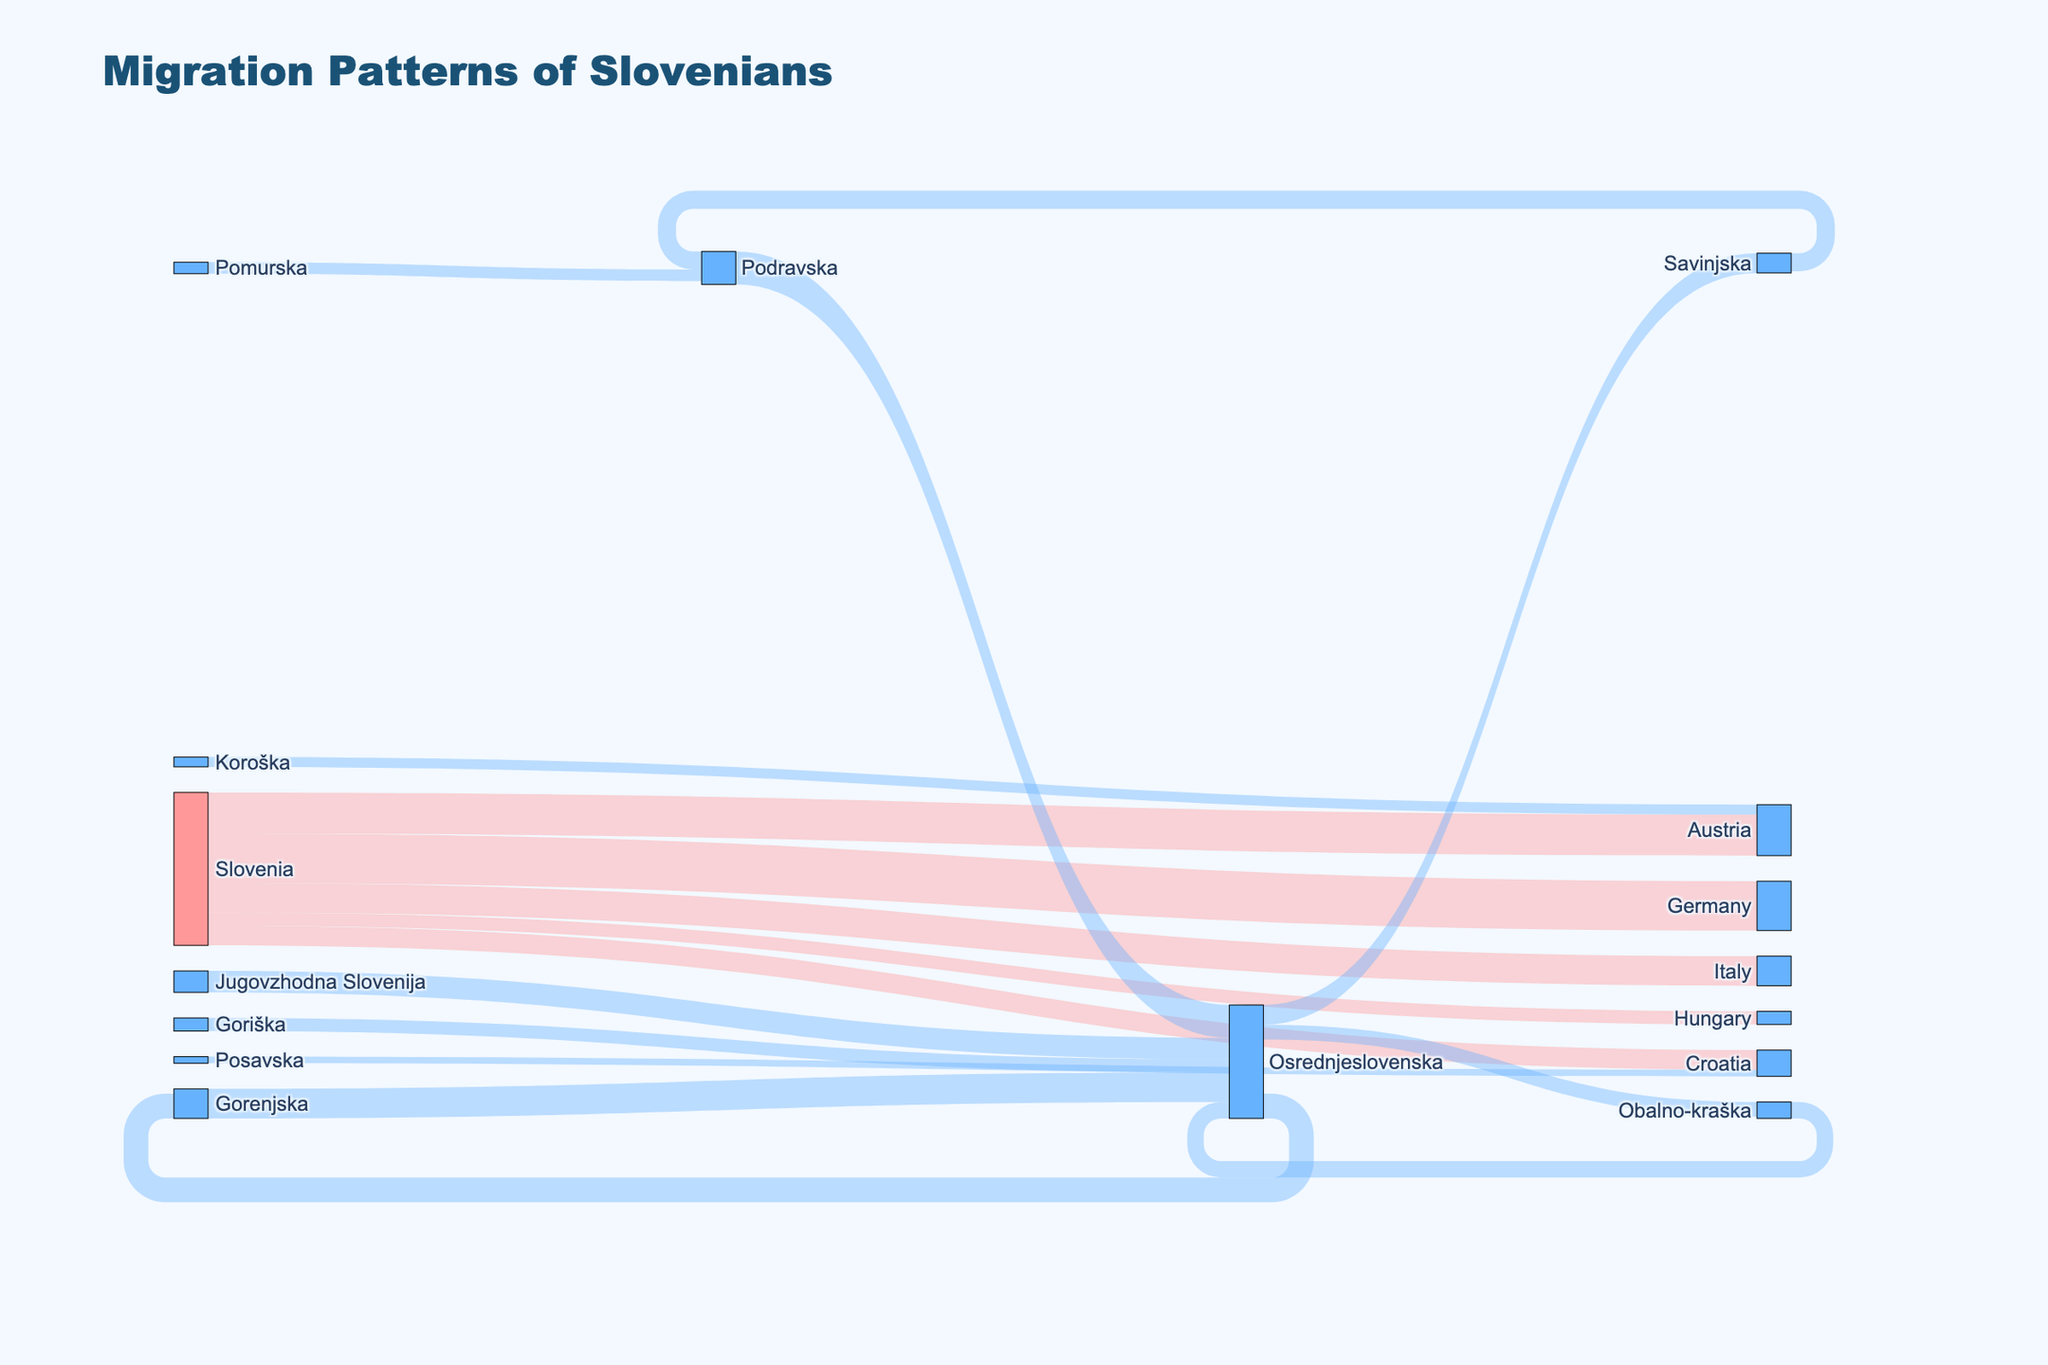What's the title of the figure? The title of the figure is displayed prominently at the top and reads "Migration Patterns of Slovenians".
Answer: Migration Patterns of Slovenians How many regions are listed as sources of migration within Slovenia? The figure shows the regions within Slovenia that are sources of migration, which are Osrednjeslovenska, Podravska, Gorenjska, Savinjska, Goriška, Jugovzhodna Slovenija, Pomurska, Obalno-kraška, Koroška, and Posavska.
Answer: 10 What is the total number of Slovenians migrating to Germany? The figure shows a flow from Slovenia to Germany with a value indicating the number of migrants. Based on the data provided, 3000 people migrate from Slovenia to Germany.
Answer: 3000 Compare the number of people migrating from Slovenia to Austria with those migrating from Slovenia to Italy. Which is higher and by how much? From the figure, we see that 2500 people migrate from Slovenia to Austria and 1800 to Italy. The difference is 2500 - 1800 = 700.
Answer: Austria by 700 From which region within Slovenia do the most people migrate to Osrednjeslovenska? The largest flow to Osrednjeslovenska from within Slovenia can be identified visually. The figure shows that the highest number of migrants come from Gorenjska with a value of 1800.
Answer: Gorenjska What is the sum of people migrating from Osrednjeslovenska to other regions within Slovenia? The outflows from Osrednjeslovenska to other regions within Slovenia include 1500 to Gorenjska, 1200 to Savinjska, and 900 to Obalno-kraška. The total is 1500 + 1200 + 900 = 3600.
Answer: 3600 How does the number of people migrating from Koroška to Austria compare with those migrating from Posavska to Croatia? The figure shows Koroška to Austria with 600 and Posavska to Croatia with 400. Comparing these, 600 is greater than 400 by 600 - 400 = 200.
Answer: Koroška to Austria by 200 Identify the region within Slovenia that receives the most migrants from other regions. By looking at the thicker flows into regions within Slovenia, Osrednjeslovenska receives the most migrants, with significant inflows from multiple regions.
Answer: Osrednjeslovenska What percentage of total international migrations from Slovenia is to Germany? Combining all international migrations from Slovenia: 2500 + 3000 + 1800 + 1200 + 800 = 9300. The percentage to Germany is (3000 / 9300) * 100% ≈ 32.26%.
Answer: 32.26% Which internal migration within Slovenia has the smallest flow? The smallest internal flow within Slovenia is from Pomurska to Podravska, with a value of 700, as depicted in the figure.
Answer: Pomurska to Podravska 